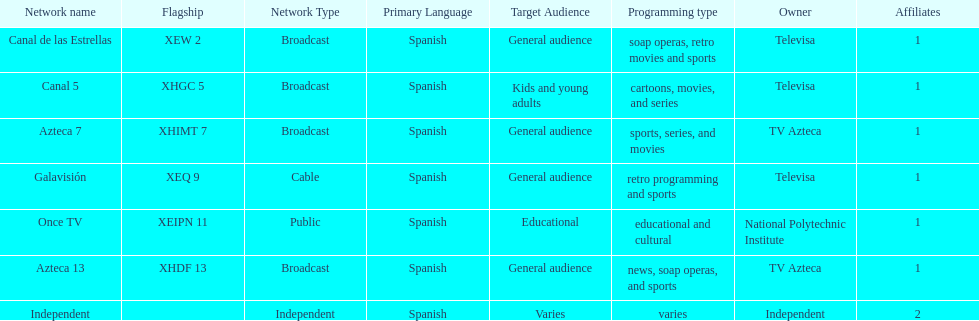Can you parse all the data within this table? {'header': ['Network name', 'Flagship', 'Network Type', 'Primary Language', 'Target Audience', 'Programming type', 'Owner', 'Affiliates'], 'rows': [['Canal de las Estrellas', 'XEW 2', 'Broadcast', 'Spanish', 'General audience', 'soap operas, retro movies and sports', 'Televisa', '1'], ['Canal 5', 'XHGC 5', 'Broadcast', 'Spanish', 'Kids and young adults', 'cartoons, movies, and series', 'Televisa', '1'], ['Azteca 7', 'XHIMT 7', 'Broadcast', 'Spanish', 'General audience', 'sports, series, and movies', 'TV Azteca', '1'], ['Galavisión', 'XEQ 9', 'Cable', 'Spanish', 'General audience', 'retro programming and sports', 'Televisa', '1'], ['Once TV', 'XEIPN 11', 'Public', 'Spanish', 'Educational', 'educational and cultural', 'National Polytechnic Institute', '1'], ['Azteca 13', 'XHDF 13', 'Broadcast', 'Spanish', 'General audience', 'news, soap operas, and sports', 'TV Azteca', '1'], ['Independent', '', 'Independent', 'Spanish', 'Varies', 'varies', 'Independent', '2']]} What is the difference between the number of affiliates galavision has and the number of affiliates azteca 13 has? 0. 